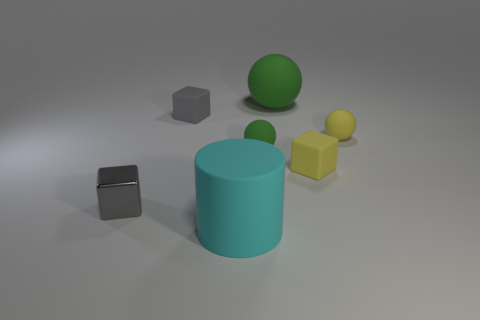Subtract all gray cubes. How many cubes are left? 1 Subtract all green spheres. How many spheres are left? 1 Subtract all spheres. How many objects are left? 4 Add 1 rubber spheres. How many objects exist? 8 Subtract 1 balls. How many balls are left? 2 Subtract all green spheres. How many blue blocks are left? 0 Subtract all cyan objects. Subtract all tiny green balls. How many objects are left? 5 Add 4 yellow matte cubes. How many yellow matte cubes are left? 5 Add 1 rubber objects. How many rubber objects exist? 7 Subtract 0 cyan balls. How many objects are left? 7 